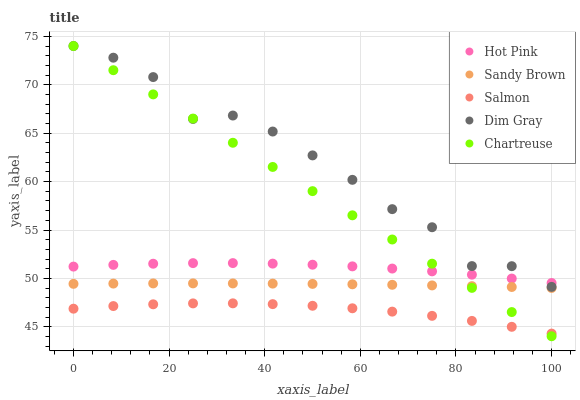Does Salmon have the minimum area under the curve?
Answer yes or no. Yes. Does Dim Gray have the maximum area under the curve?
Answer yes or no. Yes. Does Hot Pink have the minimum area under the curve?
Answer yes or no. No. Does Hot Pink have the maximum area under the curve?
Answer yes or no. No. Is Chartreuse the smoothest?
Answer yes or no. Yes. Is Dim Gray the roughest?
Answer yes or no. Yes. Is Hot Pink the smoothest?
Answer yes or no. No. Is Hot Pink the roughest?
Answer yes or no. No. Does Chartreuse have the lowest value?
Answer yes or no. Yes. Does Dim Gray have the lowest value?
Answer yes or no. No. Does Chartreuse have the highest value?
Answer yes or no. Yes. Does Hot Pink have the highest value?
Answer yes or no. No. Is Salmon less than Sandy Brown?
Answer yes or no. Yes. Is Hot Pink greater than Salmon?
Answer yes or no. Yes. Does Hot Pink intersect Dim Gray?
Answer yes or no. Yes. Is Hot Pink less than Dim Gray?
Answer yes or no. No. Is Hot Pink greater than Dim Gray?
Answer yes or no. No. Does Salmon intersect Sandy Brown?
Answer yes or no. No. 